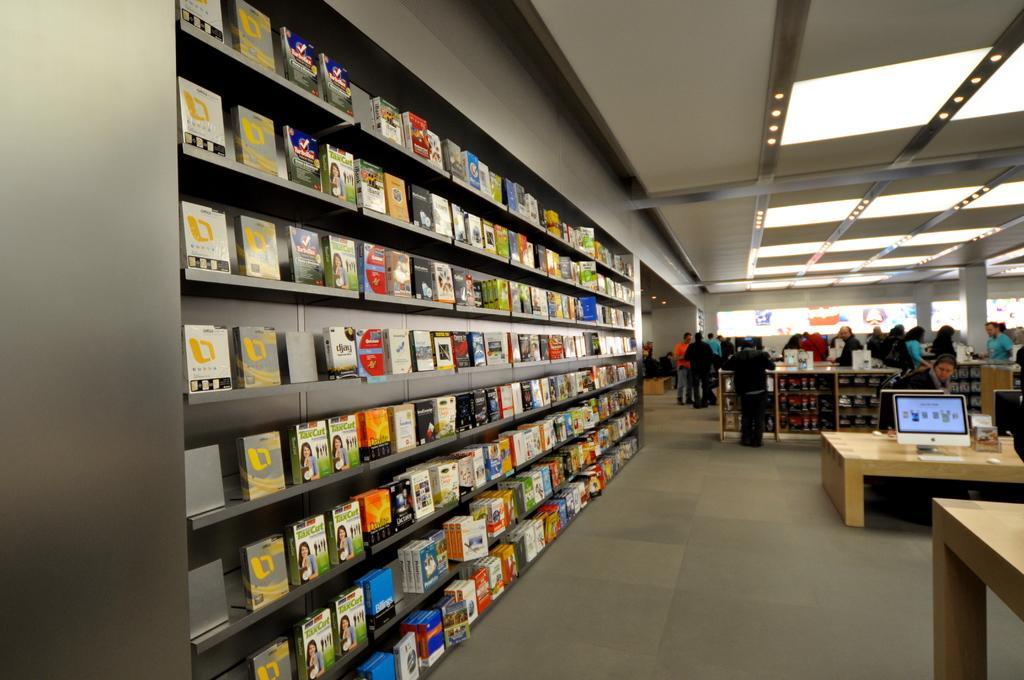How would you summarize this image in a sentence or two? This picture is clicked inside a room. There are tables to the right corner of the image. On the table there are monitors, mouse, keyboard and books. To the left corner of the image there is big rack and in it many books are placed. In the background there are many people standing at the racks. There are many lights to the ceiling and there is wall. 